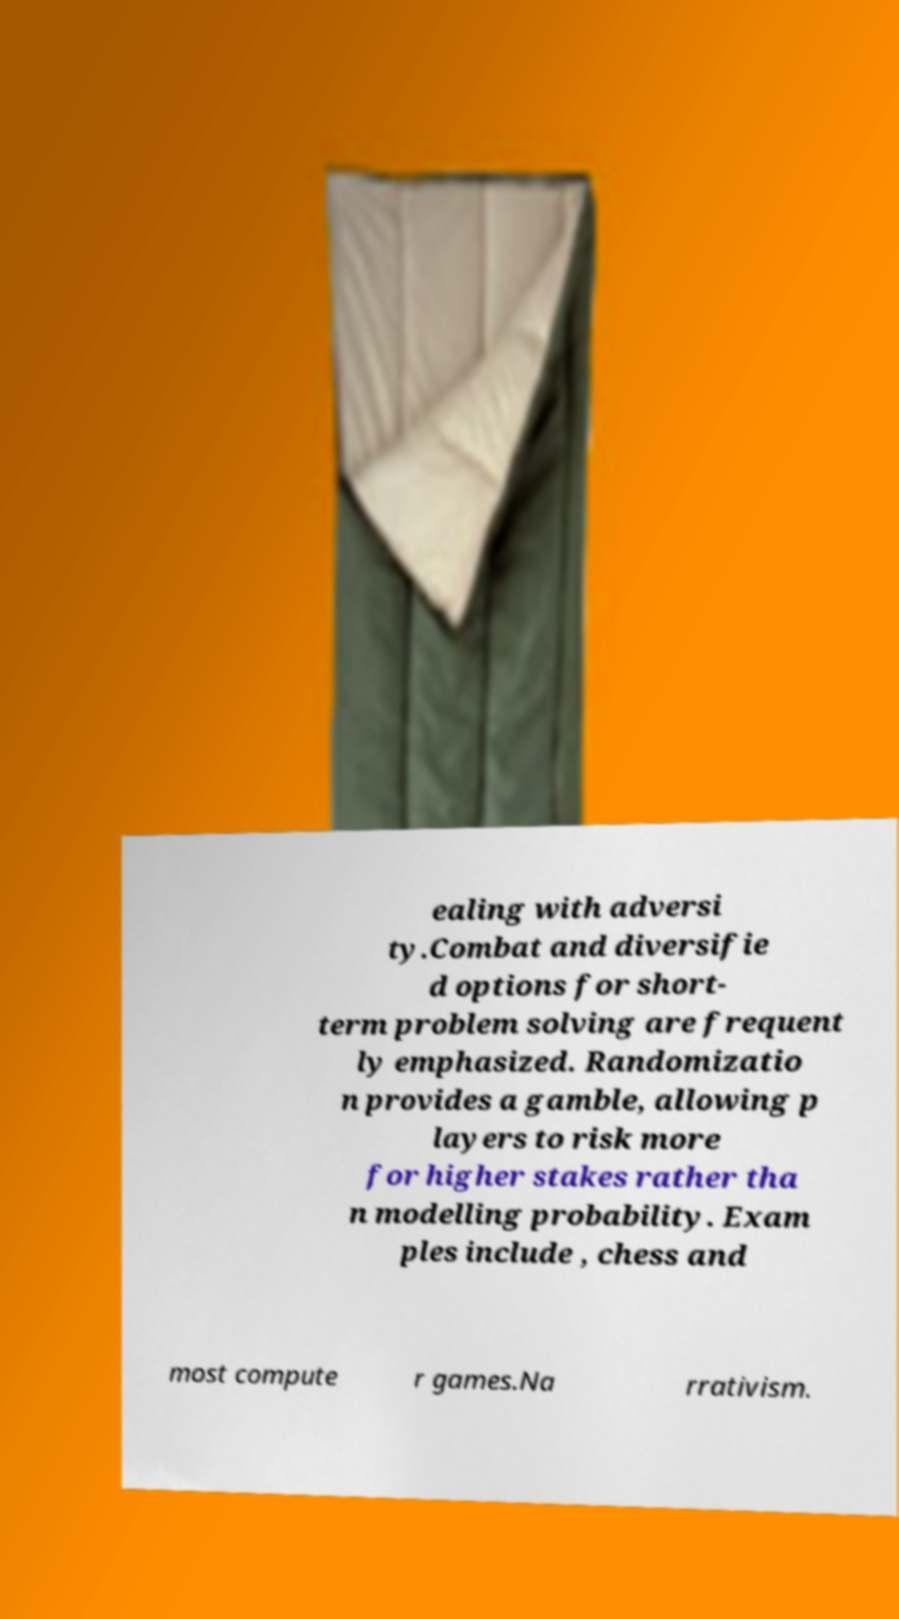Can you read and provide the text displayed in the image?This photo seems to have some interesting text. Can you extract and type it out for me? ealing with adversi ty.Combat and diversifie d options for short- term problem solving are frequent ly emphasized. Randomizatio n provides a gamble, allowing p layers to risk more for higher stakes rather tha n modelling probability. Exam ples include , chess and most compute r games.Na rrativism. 